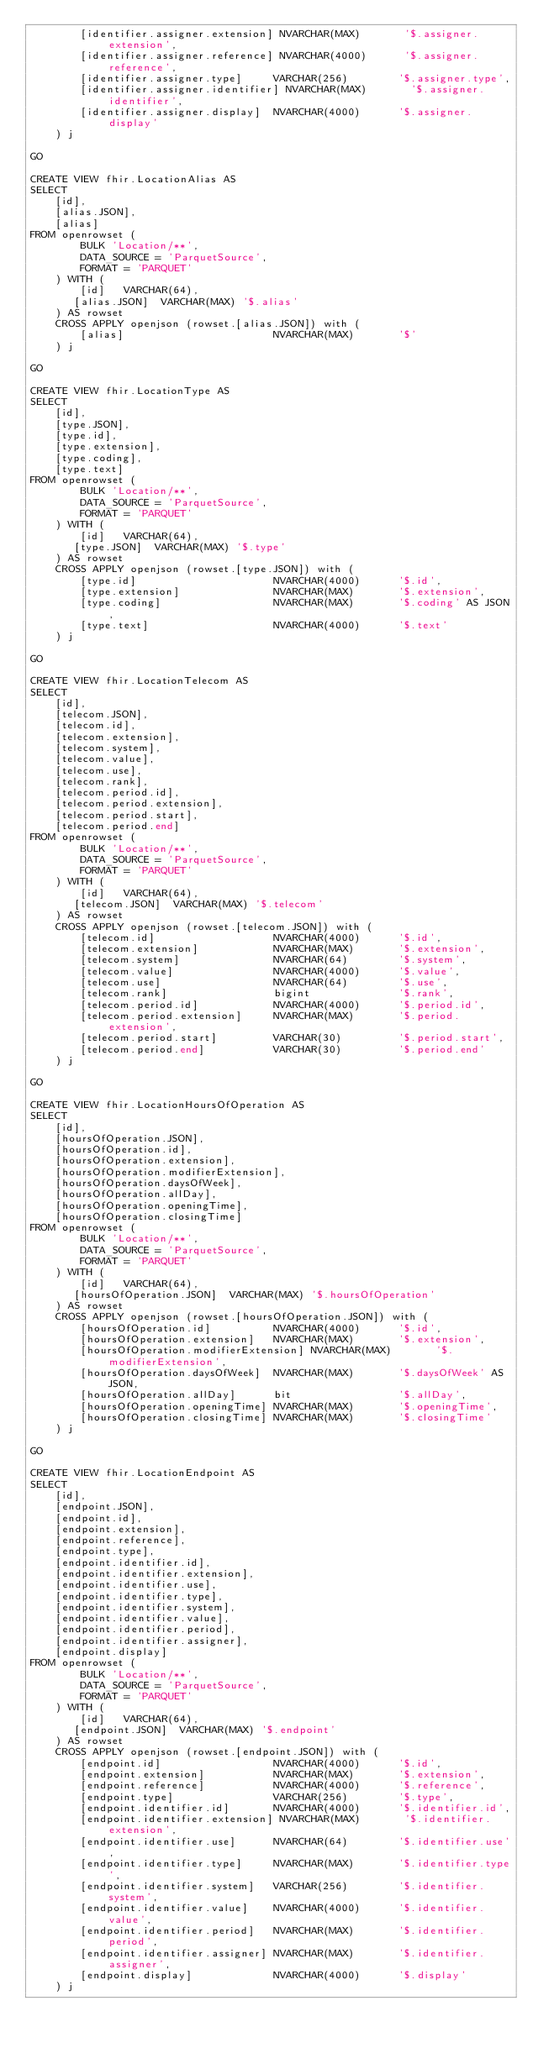Convert code to text. <code><loc_0><loc_0><loc_500><loc_500><_SQL_>        [identifier.assigner.extension] NVARCHAR(MAX)       '$.assigner.extension',
        [identifier.assigner.reference] NVARCHAR(4000)      '$.assigner.reference',
        [identifier.assigner.type]     VARCHAR(256)        '$.assigner.type',
        [identifier.assigner.identifier] NVARCHAR(MAX)       '$.assigner.identifier',
        [identifier.assigner.display]  NVARCHAR(4000)      '$.assigner.display'
    ) j

GO

CREATE VIEW fhir.LocationAlias AS
SELECT
    [id],
    [alias.JSON],
    [alias]
FROM openrowset (
        BULK 'Location/**',
        DATA_SOURCE = 'ParquetSource',
        FORMAT = 'PARQUET'
    ) WITH (
        [id]   VARCHAR(64),
       [alias.JSON]  VARCHAR(MAX) '$.alias'
    ) AS rowset
    CROSS APPLY openjson (rowset.[alias.JSON]) with (
        [alias]                        NVARCHAR(MAX)       '$'
    ) j

GO

CREATE VIEW fhir.LocationType AS
SELECT
    [id],
    [type.JSON],
    [type.id],
    [type.extension],
    [type.coding],
    [type.text]
FROM openrowset (
        BULK 'Location/**',
        DATA_SOURCE = 'ParquetSource',
        FORMAT = 'PARQUET'
    ) WITH (
        [id]   VARCHAR(64),
       [type.JSON]  VARCHAR(MAX) '$.type'
    ) AS rowset
    CROSS APPLY openjson (rowset.[type.JSON]) with (
        [type.id]                      NVARCHAR(4000)      '$.id',
        [type.extension]               NVARCHAR(MAX)       '$.extension',
        [type.coding]                  NVARCHAR(MAX)       '$.coding' AS JSON,
        [type.text]                    NVARCHAR(4000)      '$.text'
    ) j

GO

CREATE VIEW fhir.LocationTelecom AS
SELECT
    [id],
    [telecom.JSON],
    [telecom.id],
    [telecom.extension],
    [telecom.system],
    [telecom.value],
    [telecom.use],
    [telecom.rank],
    [telecom.period.id],
    [telecom.period.extension],
    [telecom.period.start],
    [telecom.period.end]
FROM openrowset (
        BULK 'Location/**',
        DATA_SOURCE = 'ParquetSource',
        FORMAT = 'PARQUET'
    ) WITH (
        [id]   VARCHAR(64),
       [telecom.JSON]  VARCHAR(MAX) '$.telecom'
    ) AS rowset
    CROSS APPLY openjson (rowset.[telecom.JSON]) with (
        [telecom.id]                   NVARCHAR(4000)      '$.id',
        [telecom.extension]            NVARCHAR(MAX)       '$.extension',
        [telecom.system]               NVARCHAR(64)        '$.system',
        [telecom.value]                NVARCHAR(4000)      '$.value',
        [telecom.use]                  NVARCHAR(64)        '$.use',
        [telecom.rank]                 bigint              '$.rank',
        [telecom.period.id]            NVARCHAR(4000)      '$.period.id',
        [telecom.period.extension]     NVARCHAR(MAX)       '$.period.extension',
        [telecom.period.start]         VARCHAR(30)         '$.period.start',
        [telecom.period.end]           VARCHAR(30)         '$.period.end'
    ) j

GO

CREATE VIEW fhir.LocationHoursOfOperation AS
SELECT
    [id],
    [hoursOfOperation.JSON],
    [hoursOfOperation.id],
    [hoursOfOperation.extension],
    [hoursOfOperation.modifierExtension],
    [hoursOfOperation.daysOfWeek],
    [hoursOfOperation.allDay],
    [hoursOfOperation.openingTime],
    [hoursOfOperation.closingTime]
FROM openrowset (
        BULK 'Location/**',
        DATA_SOURCE = 'ParquetSource',
        FORMAT = 'PARQUET'
    ) WITH (
        [id]   VARCHAR(64),
       [hoursOfOperation.JSON]  VARCHAR(MAX) '$.hoursOfOperation'
    ) AS rowset
    CROSS APPLY openjson (rowset.[hoursOfOperation.JSON]) with (
        [hoursOfOperation.id]          NVARCHAR(4000)      '$.id',
        [hoursOfOperation.extension]   NVARCHAR(MAX)       '$.extension',
        [hoursOfOperation.modifierExtension] NVARCHAR(MAX)       '$.modifierExtension',
        [hoursOfOperation.daysOfWeek]  NVARCHAR(MAX)       '$.daysOfWeek' AS JSON,
        [hoursOfOperation.allDay]      bit                 '$.allDay',
        [hoursOfOperation.openingTime] NVARCHAR(MAX)       '$.openingTime',
        [hoursOfOperation.closingTime] NVARCHAR(MAX)       '$.closingTime'
    ) j

GO

CREATE VIEW fhir.LocationEndpoint AS
SELECT
    [id],
    [endpoint.JSON],
    [endpoint.id],
    [endpoint.extension],
    [endpoint.reference],
    [endpoint.type],
    [endpoint.identifier.id],
    [endpoint.identifier.extension],
    [endpoint.identifier.use],
    [endpoint.identifier.type],
    [endpoint.identifier.system],
    [endpoint.identifier.value],
    [endpoint.identifier.period],
    [endpoint.identifier.assigner],
    [endpoint.display]
FROM openrowset (
        BULK 'Location/**',
        DATA_SOURCE = 'ParquetSource',
        FORMAT = 'PARQUET'
    ) WITH (
        [id]   VARCHAR(64),
       [endpoint.JSON]  VARCHAR(MAX) '$.endpoint'
    ) AS rowset
    CROSS APPLY openjson (rowset.[endpoint.JSON]) with (
        [endpoint.id]                  NVARCHAR(4000)      '$.id',
        [endpoint.extension]           NVARCHAR(MAX)       '$.extension',
        [endpoint.reference]           NVARCHAR(4000)      '$.reference',
        [endpoint.type]                VARCHAR(256)        '$.type',
        [endpoint.identifier.id]       NVARCHAR(4000)      '$.identifier.id',
        [endpoint.identifier.extension] NVARCHAR(MAX)       '$.identifier.extension',
        [endpoint.identifier.use]      NVARCHAR(64)        '$.identifier.use',
        [endpoint.identifier.type]     NVARCHAR(MAX)       '$.identifier.type',
        [endpoint.identifier.system]   VARCHAR(256)        '$.identifier.system',
        [endpoint.identifier.value]    NVARCHAR(4000)      '$.identifier.value',
        [endpoint.identifier.period]   NVARCHAR(MAX)       '$.identifier.period',
        [endpoint.identifier.assigner] NVARCHAR(MAX)       '$.identifier.assigner',
        [endpoint.display]             NVARCHAR(4000)      '$.display'
    ) j
</code> 